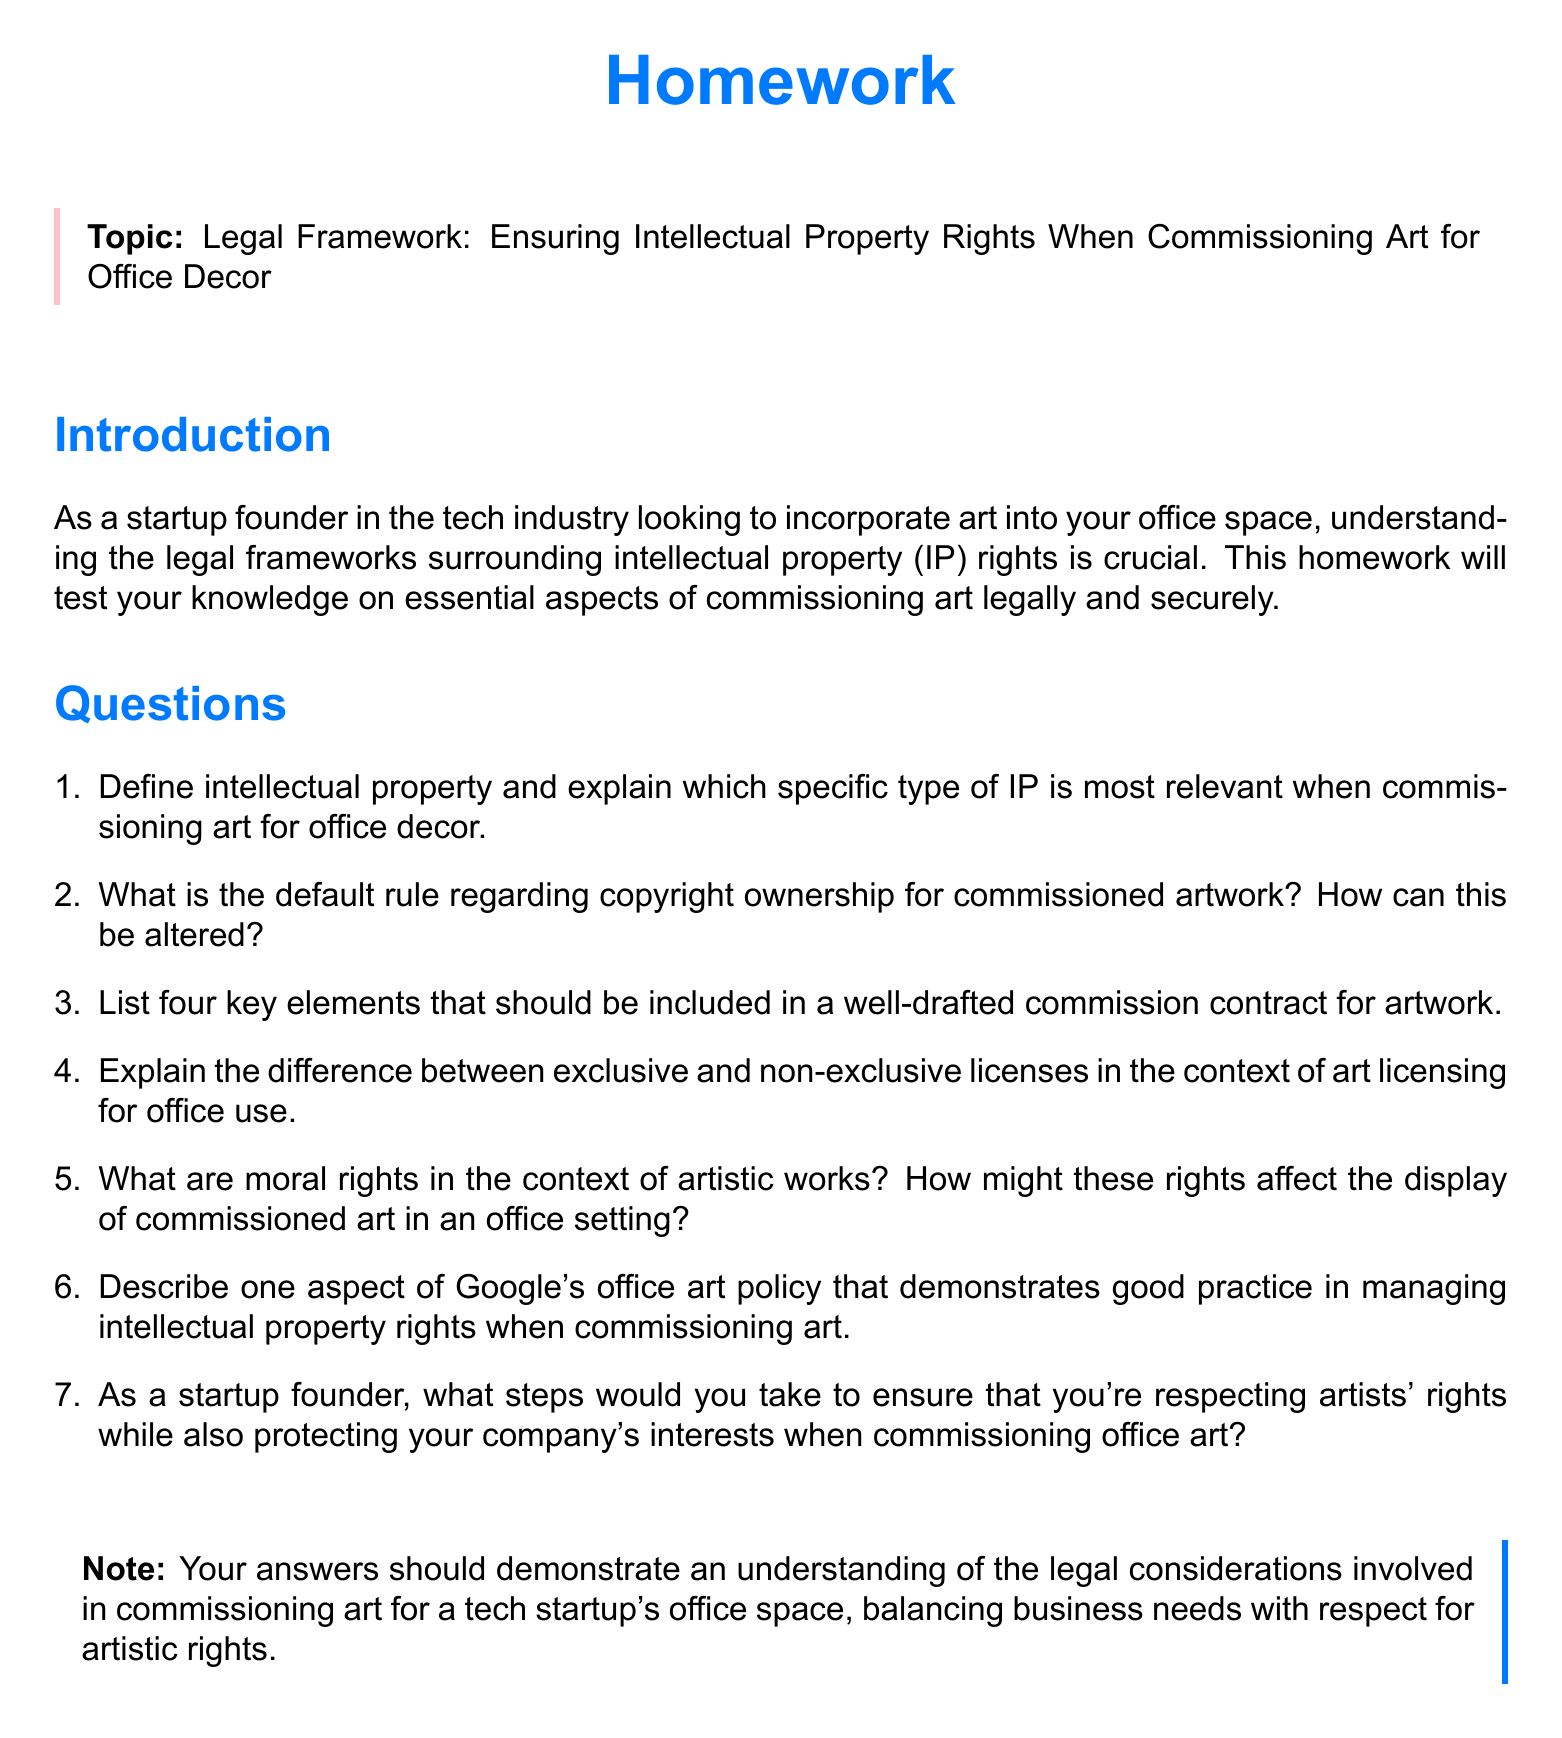What is the topic of the homework? The topic is explicitly stated in the framed section of the document, focusing on legal frameworks related to art commissioning.
Answer: Legal Framework: Ensuring Intellectual Property Rights When Commissioning Art for Office Decor How many questions are included in the homework? The number of questions can be counted in the enumeration within the questions section.
Answer: Seven What color is used for the title of the homework? The color used for the title is specified within the document's formatting commands.
Answer: Techblue What type of rights are discussed in the context of artistic works? The document mentions specific rights that relate to artistic works within the context of legal frameworks.
Answer: Moral rights What is one practice of Google's office art policy mentioned? The homework invites students to describe a good practice but does not provide specific details; the answer will be derived from external knowledge.
Answer: Good practice in managing IP rights What should be included in a well-drafted commission contract? The question prompts listing multiple elements but does not define them in the document itself, thus requiring synthesis beyond direct content.
Answer: Four key elements What is the default rule regarding copyright ownership for commissioned artwork? The document asks for an explanation but does not explicitly provide one; the answer must be inferred.
Answer: Not specified in the document 